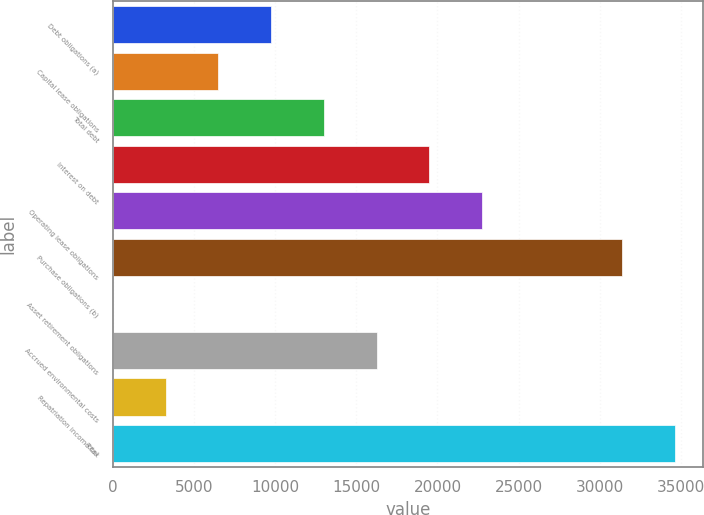Convert chart to OTSL. <chart><loc_0><loc_0><loc_500><loc_500><bar_chart><fcel>Debt obligations (a)<fcel>Capital lease obligations<fcel>Total debt<fcel>Interest on debt<fcel>Operating lease obligations<fcel>Purchase obligations (b)<fcel>Asset retirement obligations<fcel>Accrued environmental costs<fcel>Repatriation income tax<fcel>Total<nl><fcel>9758.2<fcel>6507.8<fcel>13008.6<fcel>19509.4<fcel>22759.8<fcel>31361<fcel>7<fcel>16259<fcel>3257.4<fcel>34611.4<nl></chart> 